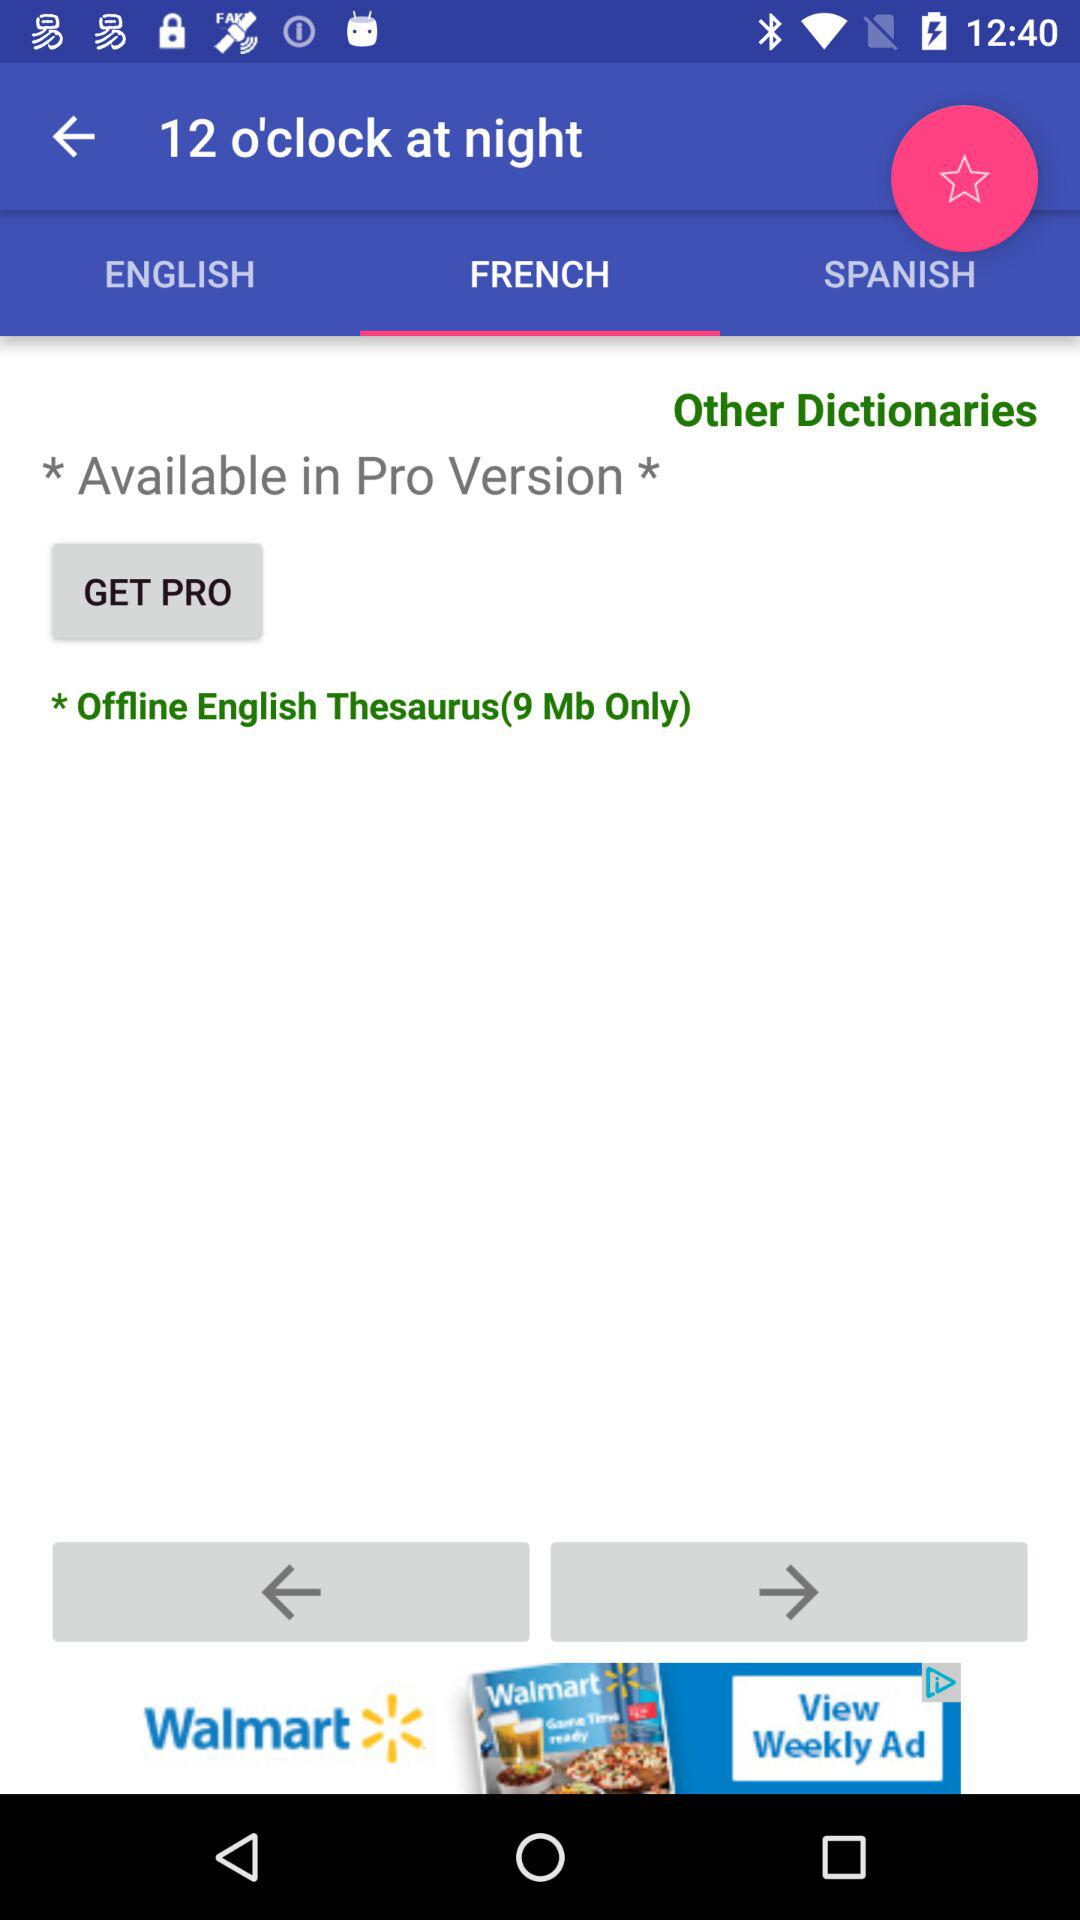What is the time? The time is 12 o'clock. 